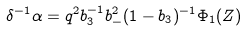<formula> <loc_0><loc_0><loc_500><loc_500>\delta ^ { - 1 } \alpha = q ^ { 2 } b _ { 3 } ^ { - 1 } b _ { - } ^ { 2 } ( 1 - b _ { 3 } ) ^ { - 1 } \Phi _ { 1 } ( Z )</formula> 